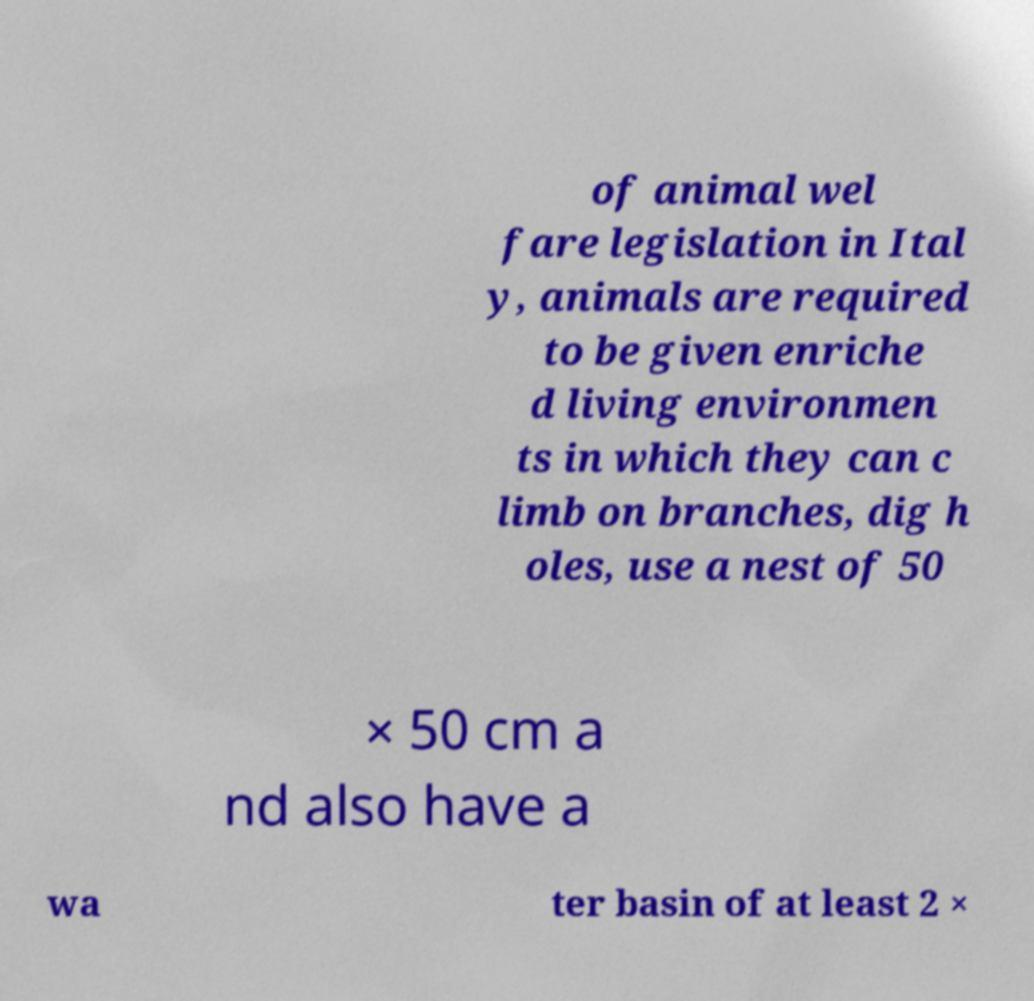Can you read and provide the text displayed in the image?This photo seems to have some interesting text. Can you extract and type it out for me? of animal wel fare legislation in Ital y, animals are required to be given enriche d living environmen ts in which they can c limb on branches, dig h oles, use a nest of 50 × 50 cm a nd also have a wa ter basin of at least 2 × 